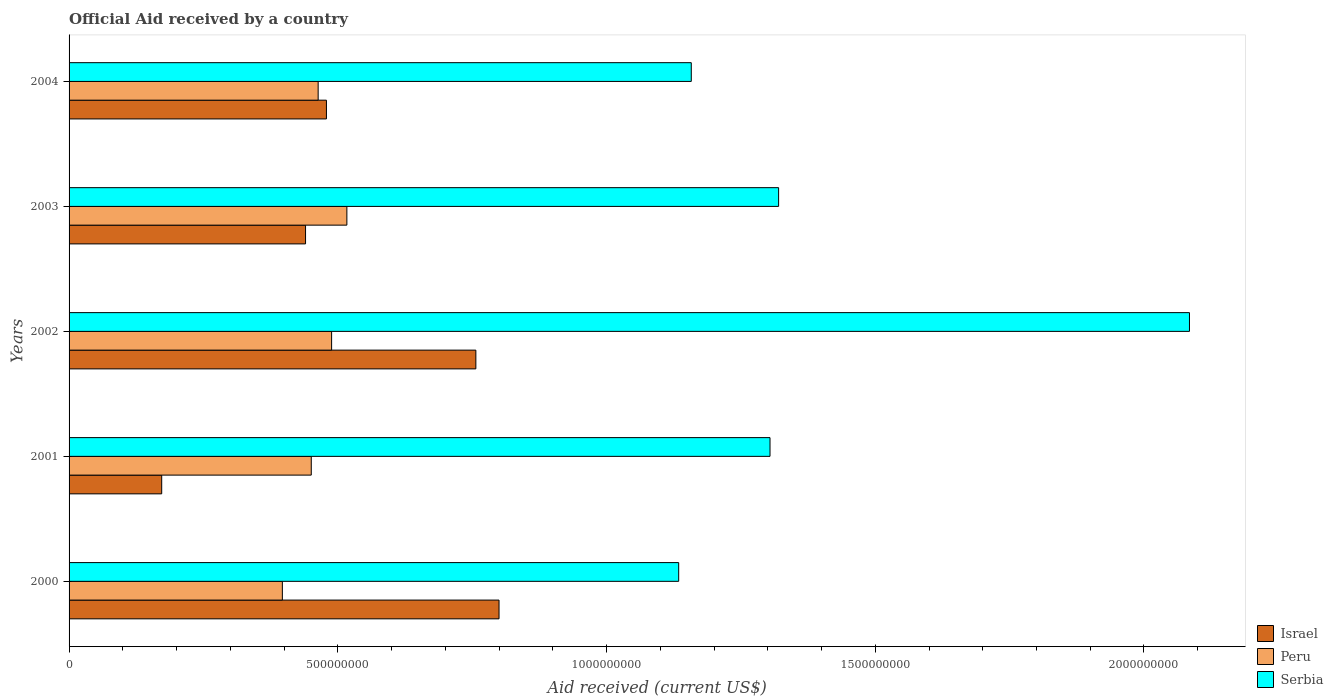How many different coloured bars are there?
Offer a terse response. 3. How many groups of bars are there?
Your answer should be very brief. 5. Are the number of bars per tick equal to the number of legend labels?
Give a very brief answer. Yes. What is the label of the 2nd group of bars from the top?
Your response must be concise. 2003. In how many cases, is the number of bars for a given year not equal to the number of legend labels?
Provide a succinct answer. 0. What is the net official aid received in Serbia in 2001?
Offer a very short reply. 1.30e+09. Across all years, what is the maximum net official aid received in Peru?
Keep it short and to the point. 5.17e+08. Across all years, what is the minimum net official aid received in Serbia?
Offer a terse response. 1.13e+09. In which year was the net official aid received in Serbia minimum?
Provide a succinct answer. 2000. What is the total net official aid received in Israel in the graph?
Offer a very short reply. 2.65e+09. What is the difference between the net official aid received in Serbia in 2000 and that in 2004?
Keep it short and to the point. -2.34e+07. What is the difference between the net official aid received in Israel in 2000 and the net official aid received in Serbia in 2001?
Offer a terse response. -5.04e+08. What is the average net official aid received in Israel per year?
Offer a very short reply. 5.30e+08. In the year 2000, what is the difference between the net official aid received in Serbia and net official aid received in Israel?
Ensure brevity in your answer.  3.34e+08. What is the ratio of the net official aid received in Israel in 2002 to that in 2004?
Keep it short and to the point. 1.58. What is the difference between the highest and the second highest net official aid received in Peru?
Offer a very short reply. 2.84e+07. What is the difference between the highest and the lowest net official aid received in Israel?
Your answer should be compact. 6.28e+08. What does the 2nd bar from the bottom in 2002 represents?
Your answer should be very brief. Peru. Is it the case that in every year, the sum of the net official aid received in Serbia and net official aid received in Peru is greater than the net official aid received in Israel?
Offer a very short reply. Yes. How many bars are there?
Your answer should be compact. 15. How many years are there in the graph?
Your answer should be very brief. 5. Are the values on the major ticks of X-axis written in scientific E-notation?
Provide a succinct answer. No. Does the graph contain any zero values?
Provide a short and direct response. No. How many legend labels are there?
Ensure brevity in your answer.  3. What is the title of the graph?
Ensure brevity in your answer.  Official Aid received by a country. Does "Turkmenistan" appear as one of the legend labels in the graph?
Your answer should be very brief. No. What is the label or title of the X-axis?
Keep it short and to the point. Aid received (current US$). What is the Aid received (current US$) in Israel in 2000?
Offer a terse response. 8.00e+08. What is the Aid received (current US$) in Peru in 2000?
Make the answer very short. 3.97e+08. What is the Aid received (current US$) in Serbia in 2000?
Offer a very short reply. 1.13e+09. What is the Aid received (current US$) of Israel in 2001?
Ensure brevity in your answer.  1.72e+08. What is the Aid received (current US$) in Peru in 2001?
Your answer should be very brief. 4.51e+08. What is the Aid received (current US$) in Serbia in 2001?
Your answer should be compact. 1.30e+09. What is the Aid received (current US$) of Israel in 2002?
Your answer should be very brief. 7.57e+08. What is the Aid received (current US$) of Peru in 2002?
Provide a short and direct response. 4.88e+08. What is the Aid received (current US$) of Serbia in 2002?
Your answer should be very brief. 2.08e+09. What is the Aid received (current US$) in Israel in 2003?
Make the answer very short. 4.40e+08. What is the Aid received (current US$) in Peru in 2003?
Provide a short and direct response. 5.17e+08. What is the Aid received (current US$) in Serbia in 2003?
Ensure brevity in your answer.  1.32e+09. What is the Aid received (current US$) of Israel in 2004?
Your answer should be compact. 4.79e+08. What is the Aid received (current US$) of Peru in 2004?
Make the answer very short. 4.63e+08. What is the Aid received (current US$) in Serbia in 2004?
Provide a short and direct response. 1.16e+09. Across all years, what is the maximum Aid received (current US$) in Israel?
Provide a succinct answer. 8.00e+08. Across all years, what is the maximum Aid received (current US$) of Peru?
Provide a short and direct response. 5.17e+08. Across all years, what is the maximum Aid received (current US$) in Serbia?
Keep it short and to the point. 2.08e+09. Across all years, what is the minimum Aid received (current US$) in Israel?
Provide a succinct answer. 1.72e+08. Across all years, what is the minimum Aid received (current US$) of Peru?
Offer a terse response. 3.97e+08. Across all years, what is the minimum Aid received (current US$) of Serbia?
Your answer should be very brief. 1.13e+09. What is the total Aid received (current US$) in Israel in the graph?
Your response must be concise. 2.65e+09. What is the total Aid received (current US$) of Peru in the graph?
Offer a very short reply. 2.32e+09. What is the total Aid received (current US$) in Serbia in the graph?
Your answer should be very brief. 7.00e+09. What is the difference between the Aid received (current US$) in Israel in 2000 and that in 2001?
Your answer should be very brief. 6.28e+08. What is the difference between the Aid received (current US$) in Peru in 2000 and that in 2001?
Your response must be concise. -5.38e+07. What is the difference between the Aid received (current US$) of Serbia in 2000 and that in 2001?
Offer a terse response. -1.70e+08. What is the difference between the Aid received (current US$) in Israel in 2000 and that in 2002?
Give a very brief answer. 4.31e+07. What is the difference between the Aid received (current US$) of Peru in 2000 and that in 2002?
Offer a terse response. -9.16e+07. What is the difference between the Aid received (current US$) in Serbia in 2000 and that in 2002?
Offer a terse response. -9.50e+08. What is the difference between the Aid received (current US$) in Israel in 2000 and that in 2003?
Give a very brief answer. 3.60e+08. What is the difference between the Aid received (current US$) in Peru in 2000 and that in 2003?
Ensure brevity in your answer.  -1.20e+08. What is the difference between the Aid received (current US$) of Serbia in 2000 and that in 2003?
Keep it short and to the point. -1.86e+08. What is the difference between the Aid received (current US$) in Israel in 2000 and that in 2004?
Your answer should be very brief. 3.21e+08. What is the difference between the Aid received (current US$) of Peru in 2000 and that in 2004?
Your answer should be very brief. -6.66e+07. What is the difference between the Aid received (current US$) of Serbia in 2000 and that in 2004?
Your answer should be compact. -2.34e+07. What is the difference between the Aid received (current US$) of Israel in 2001 and that in 2002?
Provide a short and direct response. -5.85e+08. What is the difference between the Aid received (current US$) in Peru in 2001 and that in 2002?
Keep it short and to the point. -3.78e+07. What is the difference between the Aid received (current US$) of Serbia in 2001 and that in 2002?
Your answer should be very brief. -7.80e+08. What is the difference between the Aid received (current US$) of Israel in 2001 and that in 2003?
Your answer should be compact. -2.68e+08. What is the difference between the Aid received (current US$) in Peru in 2001 and that in 2003?
Your response must be concise. -6.62e+07. What is the difference between the Aid received (current US$) of Serbia in 2001 and that in 2003?
Your answer should be very brief. -1.60e+07. What is the difference between the Aid received (current US$) of Israel in 2001 and that in 2004?
Keep it short and to the point. -3.06e+08. What is the difference between the Aid received (current US$) of Peru in 2001 and that in 2004?
Your answer should be very brief. -1.28e+07. What is the difference between the Aid received (current US$) in Serbia in 2001 and that in 2004?
Your response must be concise. 1.46e+08. What is the difference between the Aid received (current US$) of Israel in 2002 and that in 2003?
Your answer should be compact. 3.17e+08. What is the difference between the Aid received (current US$) in Peru in 2002 and that in 2003?
Provide a short and direct response. -2.84e+07. What is the difference between the Aid received (current US$) in Serbia in 2002 and that in 2003?
Give a very brief answer. 7.64e+08. What is the difference between the Aid received (current US$) in Israel in 2002 and that in 2004?
Make the answer very short. 2.78e+08. What is the difference between the Aid received (current US$) of Peru in 2002 and that in 2004?
Provide a succinct answer. 2.50e+07. What is the difference between the Aid received (current US$) of Serbia in 2002 and that in 2004?
Give a very brief answer. 9.27e+08. What is the difference between the Aid received (current US$) of Israel in 2003 and that in 2004?
Offer a terse response. -3.89e+07. What is the difference between the Aid received (current US$) of Peru in 2003 and that in 2004?
Your response must be concise. 5.34e+07. What is the difference between the Aid received (current US$) of Serbia in 2003 and that in 2004?
Ensure brevity in your answer.  1.62e+08. What is the difference between the Aid received (current US$) of Israel in 2000 and the Aid received (current US$) of Peru in 2001?
Give a very brief answer. 3.49e+08. What is the difference between the Aid received (current US$) in Israel in 2000 and the Aid received (current US$) in Serbia in 2001?
Offer a very short reply. -5.04e+08. What is the difference between the Aid received (current US$) in Peru in 2000 and the Aid received (current US$) in Serbia in 2001?
Provide a succinct answer. -9.07e+08. What is the difference between the Aid received (current US$) in Israel in 2000 and the Aid received (current US$) in Peru in 2002?
Ensure brevity in your answer.  3.12e+08. What is the difference between the Aid received (current US$) of Israel in 2000 and the Aid received (current US$) of Serbia in 2002?
Your answer should be very brief. -1.28e+09. What is the difference between the Aid received (current US$) in Peru in 2000 and the Aid received (current US$) in Serbia in 2002?
Keep it short and to the point. -1.69e+09. What is the difference between the Aid received (current US$) in Israel in 2000 and the Aid received (current US$) in Peru in 2003?
Offer a terse response. 2.83e+08. What is the difference between the Aid received (current US$) of Israel in 2000 and the Aid received (current US$) of Serbia in 2003?
Give a very brief answer. -5.20e+08. What is the difference between the Aid received (current US$) of Peru in 2000 and the Aid received (current US$) of Serbia in 2003?
Provide a short and direct response. -9.23e+08. What is the difference between the Aid received (current US$) in Israel in 2000 and the Aid received (current US$) in Peru in 2004?
Offer a very short reply. 3.37e+08. What is the difference between the Aid received (current US$) of Israel in 2000 and the Aid received (current US$) of Serbia in 2004?
Provide a succinct answer. -3.58e+08. What is the difference between the Aid received (current US$) of Peru in 2000 and the Aid received (current US$) of Serbia in 2004?
Offer a very short reply. -7.61e+08. What is the difference between the Aid received (current US$) of Israel in 2001 and the Aid received (current US$) of Peru in 2002?
Your response must be concise. -3.16e+08. What is the difference between the Aid received (current US$) of Israel in 2001 and the Aid received (current US$) of Serbia in 2002?
Offer a terse response. -1.91e+09. What is the difference between the Aid received (current US$) in Peru in 2001 and the Aid received (current US$) in Serbia in 2002?
Your answer should be very brief. -1.63e+09. What is the difference between the Aid received (current US$) in Israel in 2001 and the Aid received (current US$) in Peru in 2003?
Your answer should be very brief. -3.45e+08. What is the difference between the Aid received (current US$) in Israel in 2001 and the Aid received (current US$) in Serbia in 2003?
Offer a very short reply. -1.15e+09. What is the difference between the Aid received (current US$) in Peru in 2001 and the Aid received (current US$) in Serbia in 2003?
Give a very brief answer. -8.70e+08. What is the difference between the Aid received (current US$) of Israel in 2001 and the Aid received (current US$) of Peru in 2004?
Your answer should be very brief. -2.91e+08. What is the difference between the Aid received (current US$) of Israel in 2001 and the Aid received (current US$) of Serbia in 2004?
Make the answer very short. -9.85e+08. What is the difference between the Aid received (current US$) of Peru in 2001 and the Aid received (current US$) of Serbia in 2004?
Your answer should be compact. -7.07e+08. What is the difference between the Aid received (current US$) of Israel in 2002 and the Aid received (current US$) of Peru in 2003?
Your response must be concise. 2.40e+08. What is the difference between the Aid received (current US$) of Israel in 2002 and the Aid received (current US$) of Serbia in 2003?
Your answer should be compact. -5.63e+08. What is the difference between the Aid received (current US$) in Peru in 2002 and the Aid received (current US$) in Serbia in 2003?
Ensure brevity in your answer.  -8.32e+08. What is the difference between the Aid received (current US$) in Israel in 2002 and the Aid received (current US$) in Peru in 2004?
Your answer should be compact. 2.93e+08. What is the difference between the Aid received (current US$) in Israel in 2002 and the Aid received (current US$) in Serbia in 2004?
Keep it short and to the point. -4.01e+08. What is the difference between the Aid received (current US$) in Peru in 2002 and the Aid received (current US$) in Serbia in 2004?
Provide a succinct answer. -6.69e+08. What is the difference between the Aid received (current US$) in Israel in 2003 and the Aid received (current US$) in Peru in 2004?
Give a very brief answer. -2.35e+07. What is the difference between the Aid received (current US$) of Israel in 2003 and the Aid received (current US$) of Serbia in 2004?
Make the answer very short. -7.18e+08. What is the difference between the Aid received (current US$) of Peru in 2003 and the Aid received (current US$) of Serbia in 2004?
Your answer should be very brief. -6.41e+08. What is the average Aid received (current US$) in Israel per year?
Provide a succinct answer. 5.30e+08. What is the average Aid received (current US$) in Peru per year?
Give a very brief answer. 4.63e+08. What is the average Aid received (current US$) of Serbia per year?
Provide a succinct answer. 1.40e+09. In the year 2000, what is the difference between the Aid received (current US$) of Israel and Aid received (current US$) of Peru?
Offer a very short reply. 4.03e+08. In the year 2000, what is the difference between the Aid received (current US$) in Israel and Aid received (current US$) in Serbia?
Your response must be concise. -3.34e+08. In the year 2000, what is the difference between the Aid received (current US$) in Peru and Aid received (current US$) in Serbia?
Keep it short and to the point. -7.37e+08. In the year 2001, what is the difference between the Aid received (current US$) in Israel and Aid received (current US$) in Peru?
Your answer should be compact. -2.78e+08. In the year 2001, what is the difference between the Aid received (current US$) in Israel and Aid received (current US$) in Serbia?
Provide a short and direct response. -1.13e+09. In the year 2001, what is the difference between the Aid received (current US$) in Peru and Aid received (current US$) in Serbia?
Offer a very short reply. -8.54e+08. In the year 2002, what is the difference between the Aid received (current US$) of Israel and Aid received (current US$) of Peru?
Make the answer very short. 2.68e+08. In the year 2002, what is the difference between the Aid received (current US$) of Israel and Aid received (current US$) of Serbia?
Ensure brevity in your answer.  -1.33e+09. In the year 2002, what is the difference between the Aid received (current US$) of Peru and Aid received (current US$) of Serbia?
Provide a short and direct response. -1.60e+09. In the year 2003, what is the difference between the Aid received (current US$) in Israel and Aid received (current US$) in Peru?
Your answer should be very brief. -7.69e+07. In the year 2003, what is the difference between the Aid received (current US$) of Israel and Aid received (current US$) of Serbia?
Offer a terse response. -8.80e+08. In the year 2003, what is the difference between the Aid received (current US$) in Peru and Aid received (current US$) in Serbia?
Your answer should be very brief. -8.03e+08. In the year 2004, what is the difference between the Aid received (current US$) of Israel and Aid received (current US$) of Peru?
Give a very brief answer. 1.54e+07. In the year 2004, what is the difference between the Aid received (current US$) in Israel and Aid received (current US$) in Serbia?
Your answer should be compact. -6.79e+08. In the year 2004, what is the difference between the Aid received (current US$) of Peru and Aid received (current US$) of Serbia?
Your answer should be compact. -6.94e+08. What is the ratio of the Aid received (current US$) of Israel in 2000 to that in 2001?
Provide a short and direct response. 4.64. What is the ratio of the Aid received (current US$) of Peru in 2000 to that in 2001?
Give a very brief answer. 0.88. What is the ratio of the Aid received (current US$) in Serbia in 2000 to that in 2001?
Make the answer very short. 0.87. What is the ratio of the Aid received (current US$) of Israel in 2000 to that in 2002?
Your answer should be compact. 1.06. What is the ratio of the Aid received (current US$) in Peru in 2000 to that in 2002?
Provide a short and direct response. 0.81. What is the ratio of the Aid received (current US$) of Serbia in 2000 to that in 2002?
Keep it short and to the point. 0.54. What is the ratio of the Aid received (current US$) in Israel in 2000 to that in 2003?
Offer a very short reply. 1.82. What is the ratio of the Aid received (current US$) of Peru in 2000 to that in 2003?
Your answer should be compact. 0.77. What is the ratio of the Aid received (current US$) of Serbia in 2000 to that in 2003?
Provide a short and direct response. 0.86. What is the ratio of the Aid received (current US$) in Israel in 2000 to that in 2004?
Your answer should be very brief. 1.67. What is the ratio of the Aid received (current US$) of Peru in 2000 to that in 2004?
Make the answer very short. 0.86. What is the ratio of the Aid received (current US$) of Serbia in 2000 to that in 2004?
Your answer should be very brief. 0.98. What is the ratio of the Aid received (current US$) in Israel in 2001 to that in 2002?
Your answer should be very brief. 0.23. What is the ratio of the Aid received (current US$) in Peru in 2001 to that in 2002?
Ensure brevity in your answer.  0.92. What is the ratio of the Aid received (current US$) of Serbia in 2001 to that in 2002?
Offer a very short reply. 0.63. What is the ratio of the Aid received (current US$) in Israel in 2001 to that in 2003?
Your response must be concise. 0.39. What is the ratio of the Aid received (current US$) in Peru in 2001 to that in 2003?
Offer a very short reply. 0.87. What is the ratio of the Aid received (current US$) of Serbia in 2001 to that in 2003?
Your answer should be very brief. 0.99. What is the ratio of the Aid received (current US$) in Israel in 2001 to that in 2004?
Your answer should be compact. 0.36. What is the ratio of the Aid received (current US$) of Peru in 2001 to that in 2004?
Offer a very short reply. 0.97. What is the ratio of the Aid received (current US$) in Serbia in 2001 to that in 2004?
Your answer should be compact. 1.13. What is the ratio of the Aid received (current US$) of Israel in 2002 to that in 2003?
Ensure brevity in your answer.  1.72. What is the ratio of the Aid received (current US$) in Peru in 2002 to that in 2003?
Keep it short and to the point. 0.94. What is the ratio of the Aid received (current US$) in Serbia in 2002 to that in 2003?
Give a very brief answer. 1.58. What is the ratio of the Aid received (current US$) in Israel in 2002 to that in 2004?
Offer a terse response. 1.58. What is the ratio of the Aid received (current US$) in Peru in 2002 to that in 2004?
Provide a succinct answer. 1.05. What is the ratio of the Aid received (current US$) of Serbia in 2002 to that in 2004?
Make the answer very short. 1.8. What is the ratio of the Aid received (current US$) in Israel in 2003 to that in 2004?
Your answer should be very brief. 0.92. What is the ratio of the Aid received (current US$) in Peru in 2003 to that in 2004?
Offer a terse response. 1.12. What is the ratio of the Aid received (current US$) of Serbia in 2003 to that in 2004?
Provide a short and direct response. 1.14. What is the difference between the highest and the second highest Aid received (current US$) in Israel?
Offer a terse response. 4.31e+07. What is the difference between the highest and the second highest Aid received (current US$) of Peru?
Offer a very short reply. 2.84e+07. What is the difference between the highest and the second highest Aid received (current US$) in Serbia?
Ensure brevity in your answer.  7.64e+08. What is the difference between the highest and the lowest Aid received (current US$) of Israel?
Offer a very short reply. 6.28e+08. What is the difference between the highest and the lowest Aid received (current US$) in Peru?
Ensure brevity in your answer.  1.20e+08. What is the difference between the highest and the lowest Aid received (current US$) of Serbia?
Offer a very short reply. 9.50e+08. 